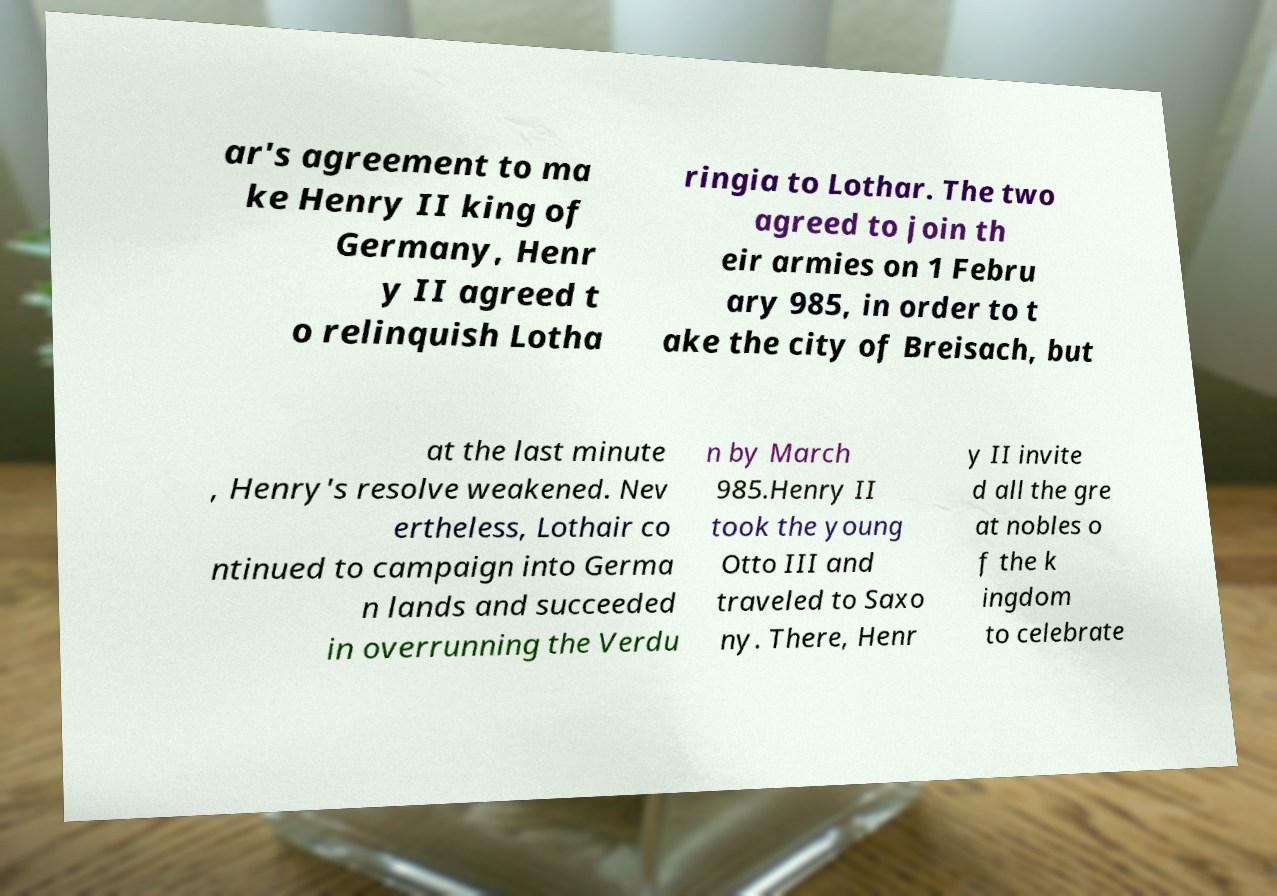Can you read and provide the text displayed in the image?This photo seems to have some interesting text. Can you extract and type it out for me? ar's agreement to ma ke Henry II king of Germany, Henr y II agreed t o relinquish Lotha ringia to Lothar. The two agreed to join th eir armies on 1 Febru ary 985, in order to t ake the city of Breisach, but at the last minute , Henry's resolve weakened. Nev ertheless, Lothair co ntinued to campaign into Germa n lands and succeeded in overrunning the Verdu n by March 985.Henry II took the young Otto III and traveled to Saxo ny. There, Henr y II invite d all the gre at nobles o f the k ingdom to celebrate 